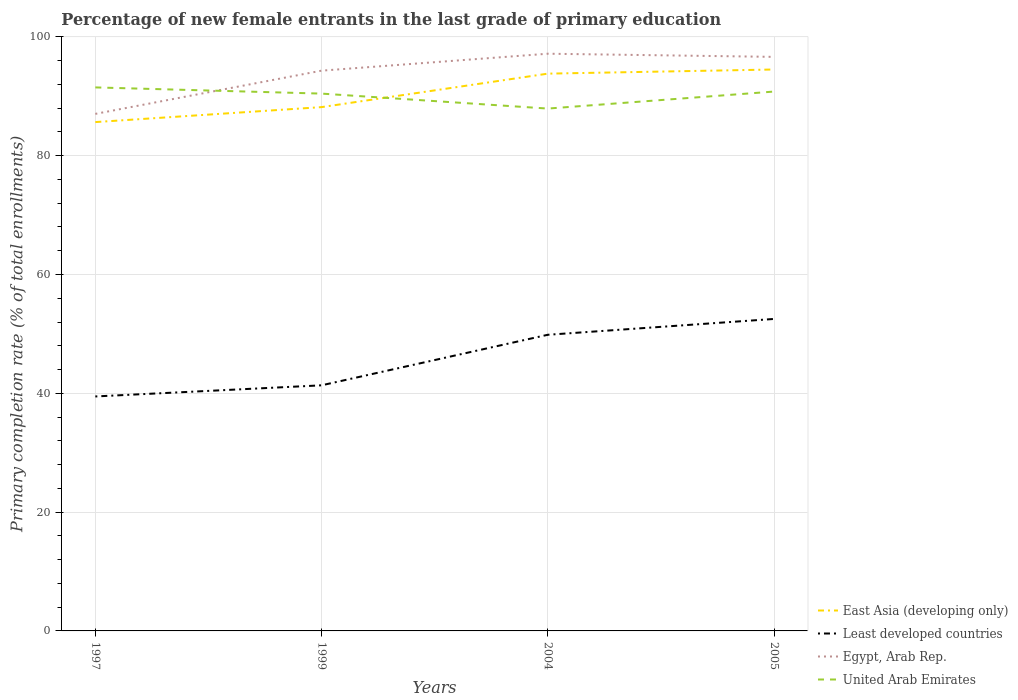Across all years, what is the maximum percentage of new female entrants in Egypt, Arab Rep.?
Your answer should be compact. 87.04. What is the total percentage of new female entrants in East Asia (developing only) in the graph?
Offer a terse response. -8.85. What is the difference between the highest and the second highest percentage of new female entrants in East Asia (developing only)?
Provide a succinct answer. 8.85. What is the difference between the highest and the lowest percentage of new female entrants in Least developed countries?
Your answer should be compact. 2. Is the percentage of new female entrants in Least developed countries strictly greater than the percentage of new female entrants in United Arab Emirates over the years?
Your response must be concise. Yes. How many lines are there?
Ensure brevity in your answer.  4. Are the values on the major ticks of Y-axis written in scientific E-notation?
Give a very brief answer. No. Where does the legend appear in the graph?
Ensure brevity in your answer.  Bottom right. How many legend labels are there?
Give a very brief answer. 4. How are the legend labels stacked?
Give a very brief answer. Vertical. What is the title of the graph?
Keep it short and to the point. Percentage of new female entrants in the last grade of primary education. Does "Northern Mariana Islands" appear as one of the legend labels in the graph?
Provide a succinct answer. No. What is the label or title of the Y-axis?
Provide a succinct answer. Primary completion rate (% of total enrollments). What is the Primary completion rate (% of total enrollments) of East Asia (developing only) in 1997?
Your response must be concise. 85.65. What is the Primary completion rate (% of total enrollments) of Least developed countries in 1997?
Offer a terse response. 39.47. What is the Primary completion rate (% of total enrollments) in Egypt, Arab Rep. in 1997?
Your response must be concise. 87.04. What is the Primary completion rate (% of total enrollments) in United Arab Emirates in 1997?
Make the answer very short. 91.49. What is the Primary completion rate (% of total enrollments) in East Asia (developing only) in 1999?
Offer a very short reply. 88.17. What is the Primary completion rate (% of total enrollments) of Least developed countries in 1999?
Your answer should be compact. 41.34. What is the Primary completion rate (% of total enrollments) of Egypt, Arab Rep. in 1999?
Ensure brevity in your answer.  94.31. What is the Primary completion rate (% of total enrollments) in United Arab Emirates in 1999?
Ensure brevity in your answer.  90.45. What is the Primary completion rate (% of total enrollments) in East Asia (developing only) in 2004?
Your answer should be compact. 93.81. What is the Primary completion rate (% of total enrollments) of Least developed countries in 2004?
Offer a terse response. 49.85. What is the Primary completion rate (% of total enrollments) of Egypt, Arab Rep. in 2004?
Your response must be concise. 97.16. What is the Primary completion rate (% of total enrollments) in United Arab Emirates in 2004?
Offer a very short reply. 87.93. What is the Primary completion rate (% of total enrollments) of East Asia (developing only) in 2005?
Your answer should be very brief. 94.5. What is the Primary completion rate (% of total enrollments) of Least developed countries in 2005?
Your response must be concise. 52.52. What is the Primary completion rate (% of total enrollments) in Egypt, Arab Rep. in 2005?
Give a very brief answer. 96.63. What is the Primary completion rate (% of total enrollments) in United Arab Emirates in 2005?
Your response must be concise. 90.79. Across all years, what is the maximum Primary completion rate (% of total enrollments) of East Asia (developing only)?
Your answer should be compact. 94.5. Across all years, what is the maximum Primary completion rate (% of total enrollments) in Least developed countries?
Give a very brief answer. 52.52. Across all years, what is the maximum Primary completion rate (% of total enrollments) in Egypt, Arab Rep.?
Provide a short and direct response. 97.16. Across all years, what is the maximum Primary completion rate (% of total enrollments) of United Arab Emirates?
Offer a very short reply. 91.49. Across all years, what is the minimum Primary completion rate (% of total enrollments) of East Asia (developing only)?
Ensure brevity in your answer.  85.65. Across all years, what is the minimum Primary completion rate (% of total enrollments) in Least developed countries?
Keep it short and to the point. 39.47. Across all years, what is the minimum Primary completion rate (% of total enrollments) of Egypt, Arab Rep.?
Ensure brevity in your answer.  87.04. Across all years, what is the minimum Primary completion rate (% of total enrollments) in United Arab Emirates?
Your answer should be very brief. 87.93. What is the total Primary completion rate (% of total enrollments) in East Asia (developing only) in the graph?
Provide a succinct answer. 362.14. What is the total Primary completion rate (% of total enrollments) in Least developed countries in the graph?
Your answer should be compact. 183.18. What is the total Primary completion rate (% of total enrollments) of Egypt, Arab Rep. in the graph?
Offer a terse response. 375.14. What is the total Primary completion rate (% of total enrollments) in United Arab Emirates in the graph?
Your response must be concise. 360.66. What is the difference between the Primary completion rate (% of total enrollments) of East Asia (developing only) in 1997 and that in 1999?
Your answer should be compact. -2.52. What is the difference between the Primary completion rate (% of total enrollments) of Least developed countries in 1997 and that in 1999?
Make the answer very short. -1.87. What is the difference between the Primary completion rate (% of total enrollments) in Egypt, Arab Rep. in 1997 and that in 1999?
Your answer should be compact. -7.27. What is the difference between the Primary completion rate (% of total enrollments) in United Arab Emirates in 1997 and that in 1999?
Give a very brief answer. 1.04. What is the difference between the Primary completion rate (% of total enrollments) in East Asia (developing only) in 1997 and that in 2004?
Keep it short and to the point. -8.16. What is the difference between the Primary completion rate (% of total enrollments) of Least developed countries in 1997 and that in 2004?
Provide a short and direct response. -10.38. What is the difference between the Primary completion rate (% of total enrollments) of Egypt, Arab Rep. in 1997 and that in 2004?
Your response must be concise. -10.13. What is the difference between the Primary completion rate (% of total enrollments) of United Arab Emirates in 1997 and that in 2004?
Offer a terse response. 3.56. What is the difference between the Primary completion rate (% of total enrollments) in East Asia (developing only) in 1997 and that in 2005?
Offer a terse response. -8.85. What is the difference between the Primary completion rate (% of total enrollments) of Least developed countries in 1997 and that in 2005?
Keep it short and to the point. -13.05. What is the difference between the Primary completion rate (% of total enrollments) in Egypt, Arab Rep. in 1997 and that in 2005?
Your answer should be compact. -9.59. What is the difference between the Primary completion rate (% of total enrollments) of United Arab Emirates in 1997 and that in 2005?
Give a very brief answer. 0.7. What is the difference between the Primary completion rate (% of total enrollments) in East Asia (developing only) in 1999 and that in 2004?
Your answer should be very brief. -5.63. What is the difference between the Primary completion rate (% of total enrollments) of Least developed countries in 1999 and that in 2004?
Your response must be concise. -8.51. What is the difference between the Primary completion rate (% of total enrollments) of Egypt, Arab Rep. in 1999 and that in 2004?
Provide a short and direct response. -2.85. What is the difference between the Primary completion rate (% of total enrollments) of United Arab Emirates in 1999 and that in 2004?
Provide a succinct answer. 2.52. What is the difference between the Primary completion rate (% of total enrollments) of East Asia (developing only) in 1999 and that in 2005?
Provide a succinct answer. -6.33. What is the difference between the Primary completion rate (% of total enrollments) of Least developed countries in 1999 and that in 2005?
Provide a short and direct response. -11.17. What is the difference between the Primary completion rate (% of total enrollments) of Egypt, Arab Rep. in 1999 and that in 2005?
Give a very brief answer. -2.32. What is the difference between the Primary completion rate (% of total enrollments) in United Arab Emirates in 1999 and that in 2005?
Your answer should be very brief. -0.35. What is the difference between the Primary completion rate (% of total enrollments) in East Asia (developing only) in 2004 and that in 2005?
Your answer should be very brief. -0.7. What is the difference between the Primary completion rate (% of total enrollments) in Least developed countries in 2004 and that in 2005?
Your response must be concise. -2.67. What is the difference between the Primary completion rate (% of total enrollments) in Egypt, Arab Rep. in 2004 and that in 2005?
Provide a succinct answer. 0.53. What is the difference between the Primary completion rate (% of total enrollments) in United Arab Emirates in 2004 and that in 2005?
Your answer should be very brief. -2.87. What is the difference between the Primary completion rate (% of total enrollments) of East Asia (developing only) in 1997 and the Primary completion rate (% of total enrollments) of Least developed countries in 1999?
Ensure brevity in your answer.  44.31. What is the difference between the Primary completion rate (% of total enrollments) in East Asia (developing only) in 1997 and the Primary completion rate (% of total enrollments) in Egypt, Arab Rep. in 1999?
Your response must be concise. -8.66. What is the difference between the Primary completion rate (% of total enrollments) of East Asia (developing only) in 1997 and the Primary completion rate (% of total enrollments) of United Arab Emirates in 1999?
Provide a succinct answer. -4.79. What is the difference between the Primary completion rate (% of total enrollments) in Least developed countries in 1997 and the Primary completion rate (% of total enrollments) in Egypt, Arab Rep. in 1999?
Your answer should be very brief. -54.84. What is the difference between the Primary completion rate (% of total enrollments) of Least developed countries in 1997 and the Primary completion rate (% of total enrollments) of United Arab Emirates in 1999?
Provide a short and direct response. -50.98. What is the difference between the Primary completion rate (% of total enrollments) of Egypt, Arab Rep. in 1997 and the Primary completion rate (% of total enrollments) of United Arab Emirates in 1999?
Keep it short and to the point. -3.41. What is the difference between the Primary completion rate (% of total enrollments) of East Asia (developing only) in 1997 and the Primary completion rate (% of total enrollments) of Least developed countries in 2004?
Provide a succinct answer. 35.8. What is the difference between the Primary completion rate (% of total enrollments) in East Asia (developing only) in 1997 and the Primary completion rate (% of total enrollments) in Egypt, Arab Rep. in 2004?
Provide a succinct answer. -11.51. What is the difference between the Primary completion rate (% of total enrollments) in East Asia (developing only) in 1997 and the Primary completion rate (% of total enrollments) in United Arab Emirates in 2004?
Your response must be concise. -2.27. What is the difference between the Primary completion rate (% of total enrollments) in Least developed countries in 1997 and the Primary completion rate (% of total enrollments) in Egypt, Arab Rep. in 2004?
Offer a very short reply. -57.69. What is the difference between the Primary completion rate (% of total enrollments) of Least developed countries in 1997 and the Primary completion rate (% of total enrollments) of United Arab Emirates in 2004?
Your response must be concise. -48.46. What is the difference between the Primary completion rate (% of total enrollments) of Egypt, Arab Rep. in 1997 and the Primary completion rate (% of total enrollments) of United Arab Emirates in 2004?
Give a very brief answer. -0.89. What is the difference between the Primary completion rate (% of total enrollments) of East Asia (developing only) in 1997 and the Primary completion rate (% of total enrollments) of Least developed countries in 2005?
Give a very brief answer. 33.14. What is the difference between the Primary completion rate (% of total enrollments) of East Asia (developing only) in 1997 and the Primary completion rate (% of total enrollments) of Egypt, Arab Rep. in 2005?
Keep it short and to the point. -10.98. What is the difference between the Primary completion rate (% of total enrollments) of East Asia (developing only) in 1997 and the Primary completion rate (% of total enrollments) of United Arab Emirates in 2005?
Your answer should be compact. -5.14. What is the difference between the Primary completion rate (% of total enrollments) in Least developed countries in 1997 and the Primary completion rate (% of total enrollments) in Egypt, Arab Rep. in 2005?
Make the answer very short. -57.16. What is the difference between the Primary completion rate (% of total enrollments) in Least developed countries in 1997 and the Primary completion rate (% of total enrollments) in United Arab Emirates in 2005?
Keep it short and to the point. -51.32. What is the difference between the Primary completion rate (% of total enrollments) of Egypt, Arab Rep. in 1997 and the Primary completion rate (% of total enrollments) of United Arab Emirates in 2005?
Your answer should be compact. -3.76. What is the difference between the Primary completion rate (% of total enrollments) of East Asia (developing only) in 1999 and the Primary completion rate (% of total enrollments) of Least developed countries in 2004?
Make the answer very short. 38.32. What is the difference between the Primary completion rate (% of total enrollments) of East Asia (developing only) in 1999 and the Primary completion rate (% of total enrollments) of Egypt, Arab Rep. in 2004?
Ensure brevity in your answer.  -8.99. What is the difference between the Primary completion rate (% of total enrollments) in East Asia (developing only) in 1999 and the Primary completion rate (% of total enrollments) in United Arab Emirates in 2004?
Provide a succinct answer. 0.25. What is the difference between the Primary completion rate (% of total enrollments) of Least developed countries in 1999 and the Primary completion rate (% of total enrollments) of Egypt, Arab Rep. in 2004?
Your answer should be compact. -55.82. What is the difference between the Primary completion rate (% of total enrollments) of Least developed countries in 1999 and the Primary completion rate (% of total enrollments) of United Arab Emirates in 2004?
Offer a very short reply. -46.58. What is the difference between the Primary completion rate (% of total enrollments) of Egypt, Arab Rep. in 1999 and the Primary completion rate (% of total enrollments) of United Arab Emirates in 2004?
Keep it short and to the point. 6.38. What is the difference between the Primary completion rate (% of total enrollments) of East Asia (developing only) in 1999 and the Primary completion rate (% of total enrollments) of Least developed countries in 2005?
Ensure brevity in your answer.  35.66. What is the difference between the Primary completion rate (% of total enrollments) in East Asia (developing only) in 1999 and the Primary completion rate (% of total enrollments) in Egypt, Arab Rep. in 2005?
Your answer should be compact. -8.46. What is the difference between the Primary completion rate (% of total enrollments) of East Asia (developing only) in 1999 and the Primary completion rate (% of total enrollments) of United Arab Emirates in 2005?
Give a very brief answer. -2.62. What is the difference between the Primary completion rate (% of total enrollments) of Least developed countries in 1999 and the Primary completion rate (% of total enrollments) of Egypt, Arab Rep. in 2005?
Keep it short and to the point. -55.29. What is the difference between the Primary completion rate (% of total enrollments) in Least developed countries in 1999 and the Primary completion rate (% of total enrollments) in United Arab Emirates in 2005?
Your answer should be very brief. -49.45. What is the difference between the Primary completion rate (% of total enrollments) in Egypt, Arab Rep. in 1999 and the Primary completion rate (% of total enrollments) in United Arab Emirates in 2005?
Your answer should be compact. 3.52. What is the difference between the Primary completion rate (% of total enrollments) of East Asia (developing only) in 2004 and the Primary completion rate (% of total enrollments) of Least developed countries in 2005?
Make the answer very short. 41.29. What is the difference between the Primary completion rate (% of total enrollments) of East Asia (developing only) in 2004 and the Primary completion rate (% of total enrollments) of Egypt, Arab Rep. in 2005?
Keep it short and to the point. -2.82. What is the difference between the Primary completion rate (% of total enrollments) in East Asia (developing only) in 2004 and the Primary completion rate (% of total enrollments) in United Arab Emirates in 2005?
Your response must be concise. 3.02. What is the difference between the Primary completion rate (% of total enrollments) of Least developed countries in 2004 and the Primary completion rate (% of total enrollments) of Egypt, Arab Rep. in 2005?
Provide a succinct answer. -46.78. What is the difference between the Primary completion rate (% of total enrollments) in Least developed countries in 2004 and the Primary completion rate (% of total enrollments) in United Arab Emirates in 2005?
Offer a terse response. -40.94. What is the difference between the Primary completion rate (% of total enrollments) in Egypt, Arab Rep. in 2004 and the Primary completion rate (% of total enrollments) in United Arab Emirates in 2005?
Keep it short and to the point. 6.37. What is the average Primary completion rate (% of total enrollments) in East Asia (developing only) per year?
Offer a very short reply. 90.53. What is the average Primary completion rate (% of total enrollments) of Least developed countries per year?
Keep it short and to the point. 45.79. What is the average Primary completion rate (% of total enrollments) in Egypt, Arab Rep. per year?
Give a very brief answer. 93.78. What is the average Primary completion rate (% of total enrollments) of United Arab Emirates per year?
Your answer should be compact. 90.16. In the year 1997, what is the difference between the Primary completion rate (% of total enrollments) in East Asia (developing only) and Primary completion rate (% of total enrollments) in Least developed countries?
Provide a succinct answer. 46.18. In the year 1997, what is the difference between the Primary completion rate (% of total enrollments) of East Asia (developing only) and Primary completion rate (% of total enrollments) of Egypt, Arab Rep.?
Ensure brevity in your answer.  -1.38. In the year 1997, what is the difference between the Primary completion rate (% of total enrollments) in East Asia (developing only) and Primary completion rate (% of total enrollments) in United Arab Emirates?
Your response must be concise. -5.84. In the year 1997, what is the difference between the Primary completion rate (% of total enrollments) of Least developed countries and Primary completion rate (% of total enrollments) of Egypt, Arab Rep.?
Provide a succinct answer. -47.57. In the year 1997, what is the difference between the Primary completion rate (% of total enrollments) in Least developed countries and Primary completion rate (% of total enrollments) in United Arab Emirates?
Make the answer very short. -52.02. In the year 1997, what is the difference between the Primary completion rate (% of total enrollments) of Egypt, Arab Rep. and Primary completion rate (% of total enrollments) of United Arab Emirates?
Provide a short and direct response. -4.46. In the year 1999, what is the difference between the Primary completion rate (% of total enrollments) in East Asia (developing only) and Primary completion rate (% of total enrollments) in Least developed countries?
Provide a succinct answer. 46.83. In the year 1999, what is the difference between the Primary completion rate (% of total enrollments) in East Asia (developing only) and Primary completion rate (% of total enrollments) in Egypt, Arab Rep.?
Keep it short and to the point. -6.14. In the year 1999, what is the difference between the Primary completion rate (% of total enrollments) of East Asia (developing only) and Primary completion rate (% of total enrollments) of United Arab Emirates?
Your response must be concise. -2.27. In the year 1999, what is the difference between the Primary completion rate (% of total enrollments) in Least developed countries and Primary completion rate (% of total enrollments) in Egypt, Arab Rep.?
Your answer should be very brief. -52.97. In the year 1999, what is the difference between the Primary completion rate (% of total enrollments) of Least developed countries and Primary completion rate (% of total enrollments) of United Arab Emirates?
Your answer should be compact. -49.1. In the year 1999, what is the difference between the Primary completion rate (% of total enrollments) in Egypt, Arab Rep. and Primary completion rate (% of total enrollments) in United Arab Emirates?
Provide a short and direct response. 3.86. In the year 2004, what is the difference between the Primary completion rate (% of total enrollments) in East Asia (developing only) and Primary completion rate (% of total enrollments) in Least developed countries?
Make the answer very short. 43.96. In the year 2004, what is the difference between the Primary completion rate (% of total enrollments) of East Asia (developing only) and Primary completion rate (% of total enrollments) of Egypt, Arab Rep.?
Keep it short and to the point. -3.35. In the year 2004, what is the difference between the Primary completion rate (% of total enrollments) of East Asia (developing only) and Primary completion rate (% of total enrollments) of United Arab Emirates?
Provide a short and direct response. 5.88. In the year 2004, what is the difference between the Primary completion rate (% of total enrollments) in Least developed countries and Primary completion rate (% of total enrollments) in Egypt, Arab Rep.?
Keep it short and to the point. -47.31. In the year 2004, what is the difference between the Primary completion rate (% of total enrollments) in Least developed countries and Primary completion rate (% of total enrollments) in United Arab Emirates?
Your answer should be compact. -38.08. In the year 2004, what is the difference between the Primary completion rate (% of total enrollments) of Egypt, Arab Rep. and Primary completion rate (% of total enrollments) of United Arab Emirates?
Offer a terse response. 9.23. In the year 2005, what is the difference between the Primary completion rate (% of total enrollments) of East Asia (developing only) and Primary completion rate (% of total enrollments) of Least developed countries?
Make the answer very short. 41.99. In the year 2005, what is the difference between the Primary completion rate (% of total enrollments) of East Asia (developing only) and Primary completion rate (% of total enrollments) of Egypt, Arab Rep.?
Make the answer very short. -2.12. In the year 2005, what is the difference between the Primary completion rate (% of total enrollments) in East Asia (developing only) and Primary completion rate (% of total enrollments) in United Arab Emirates?
Your answer should be compact. 3.71. In the year 2005, what is the difference between the Primary completion rate (% of total enrollments) in Least developed countries and Primary completion rate (% of total enrollments) in Egypt, Arab Rep.?
Ensure brevity in your answer.  -44.11. In the year 2005, what is the difference between the Primary completion rate (% of total enrollments) in Least developed countries and Primary completion rate (% of total enrollments) in United Arab Emirates?
Your response must be concise. -38.28. In the year 2005, what is the difference between the Primary completion rate (% of total enrollments) of Egypt, Arab Rep. and Primary completion rate (% of total enrollments) of United Arab Emirates?
Provide a succinct answer. 5.84. What is the ratio of the Primary completion rate (% of total enrollments) of East Asia (developing only) in 1997 to that in 1999?
Provide a short and direct response. 0.97. What is the ratio of the Primary completion rate (% of total enrollments) of Least developed countries in 1997 to that in 1999?
Give a very brief answer. 0.95. What is the ratio of the Primary completion rate (% of total enrollments) in Egypt, Arab Rep. in 1997 to that in 1999?
Provide a succinct answer. 0.92. What is the ratio of the Primary completion rate (% of total enrollments) of United Arab Emirates in 1997 to that in 1999?
Ensure brevity in your answer.  1.01. What is the ratio of the Primary completion rate (% of total enrollments) of East Asia (developing only) in 1997 to that in 2004?
Your answer should be compact. 0.91. What is the ratio of the Primary completion rate (% of total enrollments) in Least developed countries in 1997 to that in 2004?
Your response must be concise. 0.79. What is the ratio of the Primary completion rate (% of total enrollments) of Egypt, Arab Rep. in 1997 to that in 2004?
Your answer should be very brief. 0.9. What is the ratio of the Primary completion rate (% of total enrollments) of United Arab Emirates in 1997 to that in 2004?
Give a very brief answer. 1.04. What is the ratio of the Primary completion rate (% of total enrollments) in East Asia (developing only) in 1997 to that in 2005?
Provide a short and direct response. 0.91. What is the ratio of the Primary completion rate (% of total enrollments) of Least developed countries in 1997 to that in 2005?
Offer a terse response. 0.75. What is the ratio of the Primary completion rate (% of total enrollments) in Egypt, Arab Rep. in 1997 to that in 2005?
Offer a very short reply. 0.9. What is the ratio of the Primary completion rate (% of total enrollments) of United Arab Emirates in 1997 to that in 2005?
Your response must be concise. 1.01. What is the ratio of the Primary completion rate (% of total enrollments) in East Asia (developing only) in 1999 to that in 2004?
Provide a succinct answer. 0.94. What is the ratio of the Primary completion rate (% of total enrollments) of Least developed countries in 1999 to that in 2004?
Your answer should be compact. 0.83. What is the ratio of the Primary completion rate (% of total enrollments) of Egypt, Arab Rep. in 1999 to that in 2004?
Your answer should be compact. 0.97. What is the ratio of the Primary completion rate (% of total enrollments) in United Arab Emirates in 1999 to that in 2004?
Keep it short and to the point. 1.03. What is the ratio of the Primary completion rate (% of total enrollments) in East Asia (developing only) in 1999 to that in 2005?
Make the answer very short. 0.93. What is the ratio of the Primary completion rate (% of total enrollments) in Least developed countries in 1999 to that in 2005?
Your answer should be compact. 0.79. What is the ratio of the Primary completion rate (% of total enrollments) in Egypt, Arab Rep. in 1999 to that in 2005?
Offer a very short reply. 0.98. What is the ratio of the Primary completion rate (% of total enrollments) in Least developed countries in 2004 to that in 2005?
Your response must be concise. 0.95. What is the ratio of the Primary completion rate (% of total enrollments) in Egypt, Arab Rep. in 2004 to that in 2005?
Your answer should be compact. 1.01. What is the ratio of the Primary completion rate (% of total enrollments) of United Arab Emirates in 2004 to that in 2005?
Offer a very short reply. 0.97. What is the difference between the highest and the second highest Primary completion rate (% of total enrollments) in East Asia (developing only)?
Your answer should be very brief. 0.7. What is the difference between the highest and the second highest Primary completion rate (% of total enrollments) of Least developed countries?
Your answer should be very brief. 2.67. What is the difference between the highest and the second highest Primary completion rate (% of total enrollments) of Egypt, Arab Rep.?
Keep it short and to the point. 0.53. What is the difference between the highest and the second highest Primary completion rate (% of total enrollments) in United Arab Emirates?
Offer a very short reply. 0.7. What is the difference between the highest and the lowest Primary completion rate (% of total enrollments) of East Asia (developing only)?
Your response must be concise. 8.85. What is the difference between the highest and the lowest Primary completion rate (% of total enrollments) in Least developed countries?
Ensure brevity in your answer.  13.05. What is the difference between the highest and the lowest Primary completion rate (% of total enrollments) of Egypt, Arab Rep.?
Your answer should be compact. 10.13. What is the difference between the highest and the lowest Primary completion rate (% of total enrollments) in United Arab Emirates?
Give a very brief answer. 3.56. 